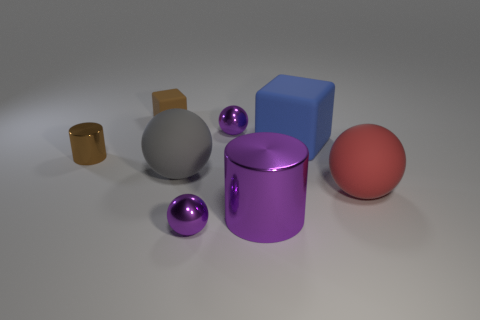There is a tiny metallic thing that is in front of the tiny cylinder; what shape is it?
Give a very brief answer. Sphere. There is a large purple object; is it the same shape as the big rubber object that is on the left side of the big purple thing?
Offer a very short reply. No. Is the number of large blue matte blocks to the right of the blue matte cube the same as the number of big blue objects right of the big purple thing?
Your response must be concise. No. There is a thing that is the same color as the small cylinder; what is its shape?
Your response must be concise. Cube. Does the shiny cylinder that is to the left of the small brown matte cube have the same color as the block that is on the left side of the big blue block?
Keep it short and to the point. Yes. Are there more big gray spheres behind the red thing than small cyan spheres?
Provide a succinct answer. Yes. What is the material of the purple cylinder?
Provide a succinct answer. Metal. There is a large blue thing that is made of the same material as the gray ball; what is its shape?
Give a very brief answer. Cube. There is a object to the left of the matte block to the left of the gray rubber thing; what is its size?
Provide a succinct answer. Small. There is a tiny rubber cube behind the large purple shiny object; what color is it?
Make the answer very short. Brown. 